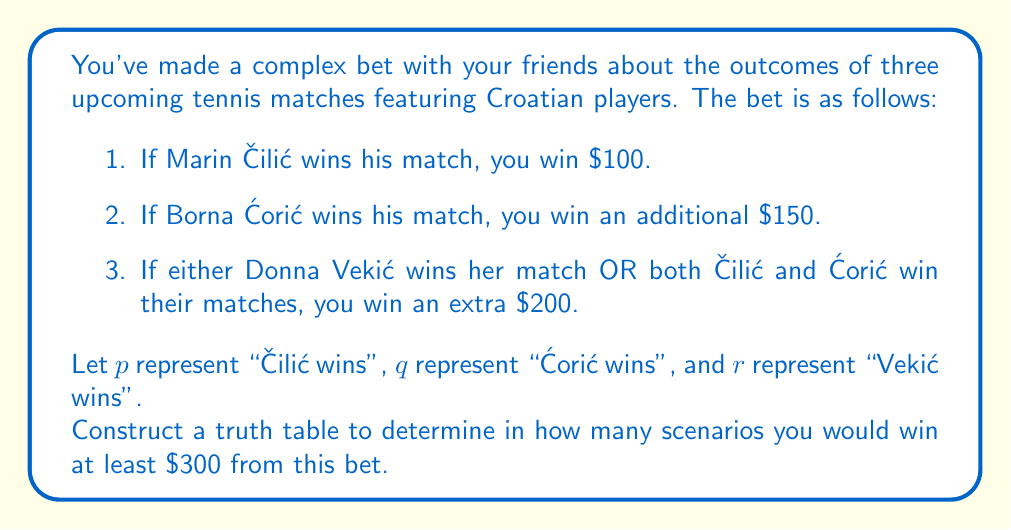Provide a solution to this math problem. Let's approach this step-by-step:

1) First, we need to construct a truth table with all possible combinations of $p$, $q$, and $r$. There will be $2^3 = 8$ rows.

2) Next, we'll add columns for each part of the bet:
   - Column A: $p$ (win $100 if true)
   - Column B: $q$ (win $150 if true)
   - Column C: $r \vee (p \wedge q)$ (win $200 if true)

3) We'll then sum up the winnings for each scenario.

4) Finally, we'll count how many scenarios result in winnings of at least $300.

Here's the truth table:

$$
\begin{array}{|c|c|c|c|c|c|c|}
\hline
p & q & r & A & B & C & \text{Total} \\
\hline
T & T & T & 100 & 150 & 200 & 450 \\
T & T & F & 100 & 150 & 200 & 450 \\
T & F & T & 100 & 0 & 200 & 300 \\
T & F & F & 100 & 0 & 0 & 100 \\
F & T & T & 0 & 150 & 200 & 350 \\
F & T & F & 0 & 150 & 0 & 150 \\
F & F & T & 0 & 0 & 200 & 200 \\
F & F & F & 0 & 0 & 0 & 0 \\
\hline
\end{array}
$$

Counting the rows where the total is at least $300, we find 4 such scenarios.
Answer: There are 4 scenarios in which you would win at least $300 from this bet. 